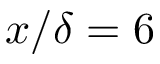Convert formula to latex. <formula><loc_0><loc_0><loc_500><loc_500>x / \delta = 6</formula> 